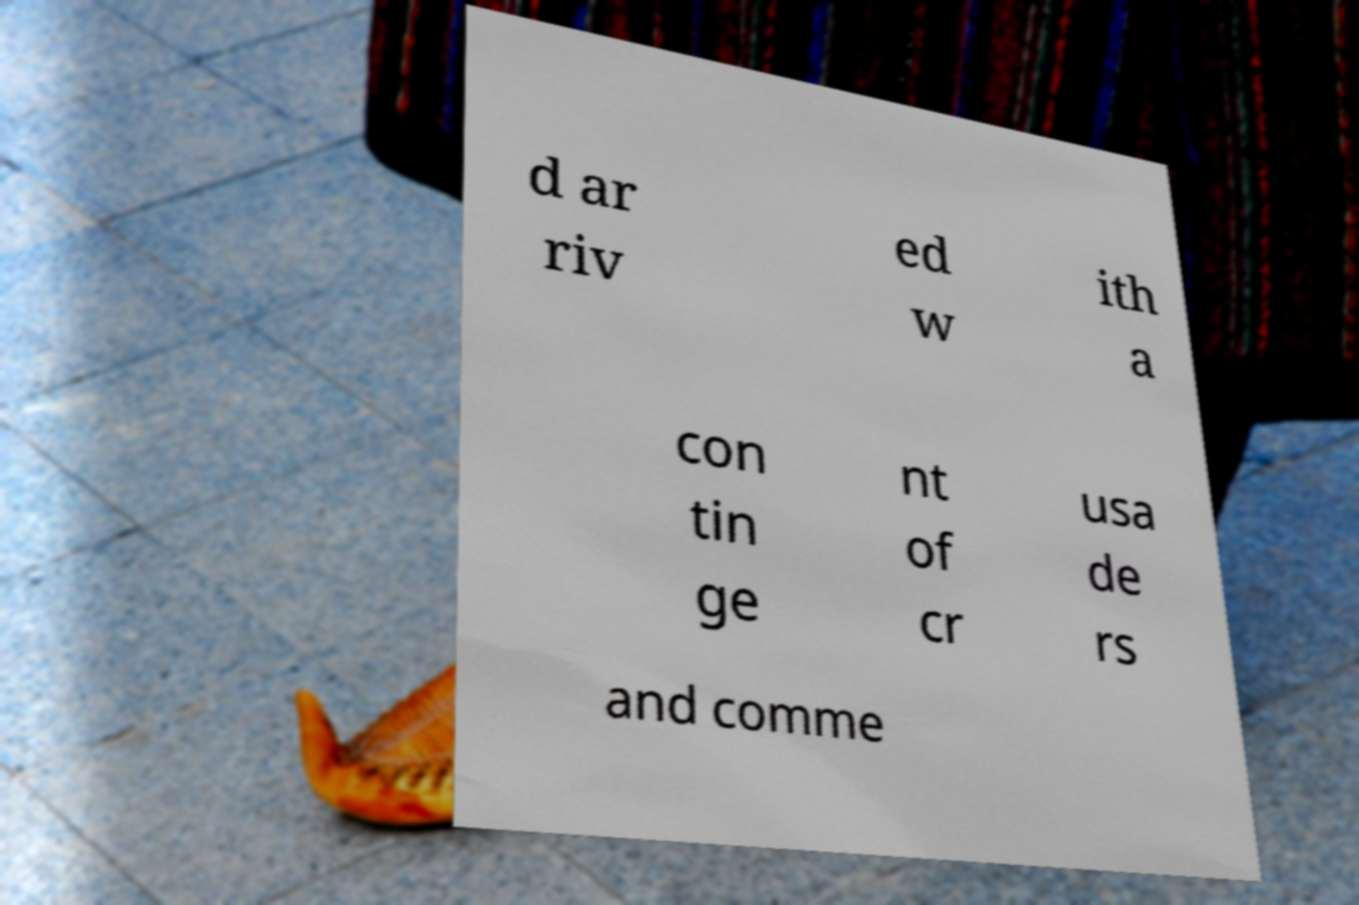Please read and relay the text visible in this image. What does it say? d ar riv ed w ith a con tin ge nt of cr usa de rs and comme 